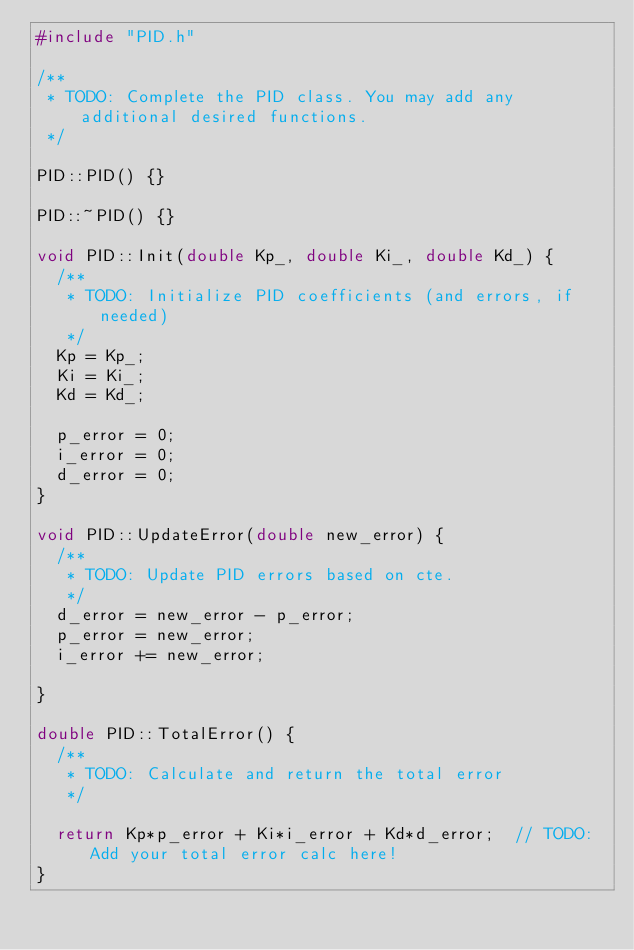<code> <loc_0><loc_0><loc_500><loc_500><_C++_>#include "PID.h"

/**
 * TODO: Complete the PID class. You may add any additional desired functions.
 */

PID::PID() {}

PID::~PID() {}

void PID::Init(double Kp_, double Ki_, double Kd_) {
  /**
   * TODO: Initialize PID coefficients (and errors, if needed)
   */
  Kp = Kp_;
  Ki = Ki_;
  Kd = Kd_;

  p_error = 0;
  i_error = 0;
  d_error = 0;
}

void PID::UpdateError(double new_error) {
  /**
   * TODO: Update PID errors based on cte.
   */
  d_error = new_error - p_error;
  p_error = new_error;
  i_error += new_error;  

}

double PID::TotalError() {
  /**
   * TODO: Calculate and return the total error
   */
  
  return Kp*p_error + Ki*i_error + Kd*d_error;  // TODO: Add your total error calc here!
}</code> 